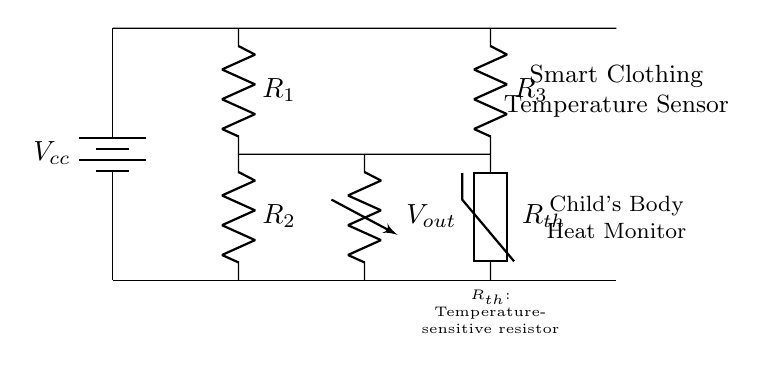What is the power supply voltage for this circuit? The power supply voltage, denoted as Vcc, is the voltage provided to the circuit from the battery, which can be seen at the top left corner of the diagram.
Answer: Vcc How many resistors are present in the circuit? The circuit diagram shows three resistors (R1, R2, and R3), as indicated by the resistance symbols and their labels.
Answer: Three What type of thermistor is used in this circuit? The diagram labels the thermistor as Rth, implying it is a temperature-sensitive resistor. This means it changes its resistance based on temperature.
Answer: Temperature-sensitive resistor What is the function of the R1 resistor in this bridge configuration? Resistor R1 is part of the voltage divider formed in the bridge circuit, which is crucial for measuring the voltage output that relates to the temperature sensed by Rth.
Answer: Voltage divider What is the output voltage point labeled as? The output voltage point in the circuit is indicated as Vout, which is the voltage measured across the sensor system related to the temperature monitoring function.
Answer: Vout How does the bridge circuit help in temperature sensing? The bridge circuit compares the resistance of the thermistor Rth to the resistances of the other resistors (R1, R2, and R3), allowing it to measure changes in temperature based on the voltage difference created in the circuit.
Answer: Measures temperature by voltage difference 